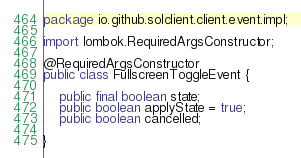Convert code to text. <code><loc_0><loc_0><loc_500><loc_500><_Java_>package io.github.solclient.client.event.impl;

import lombok.RequiredArgsConstructor;

@RequiredArgsConstructor
public class FullscreenToggleEvent {

	public final boolean state;
	public boolean applyState = true;
	public boolean cancelled;

}
</code> 